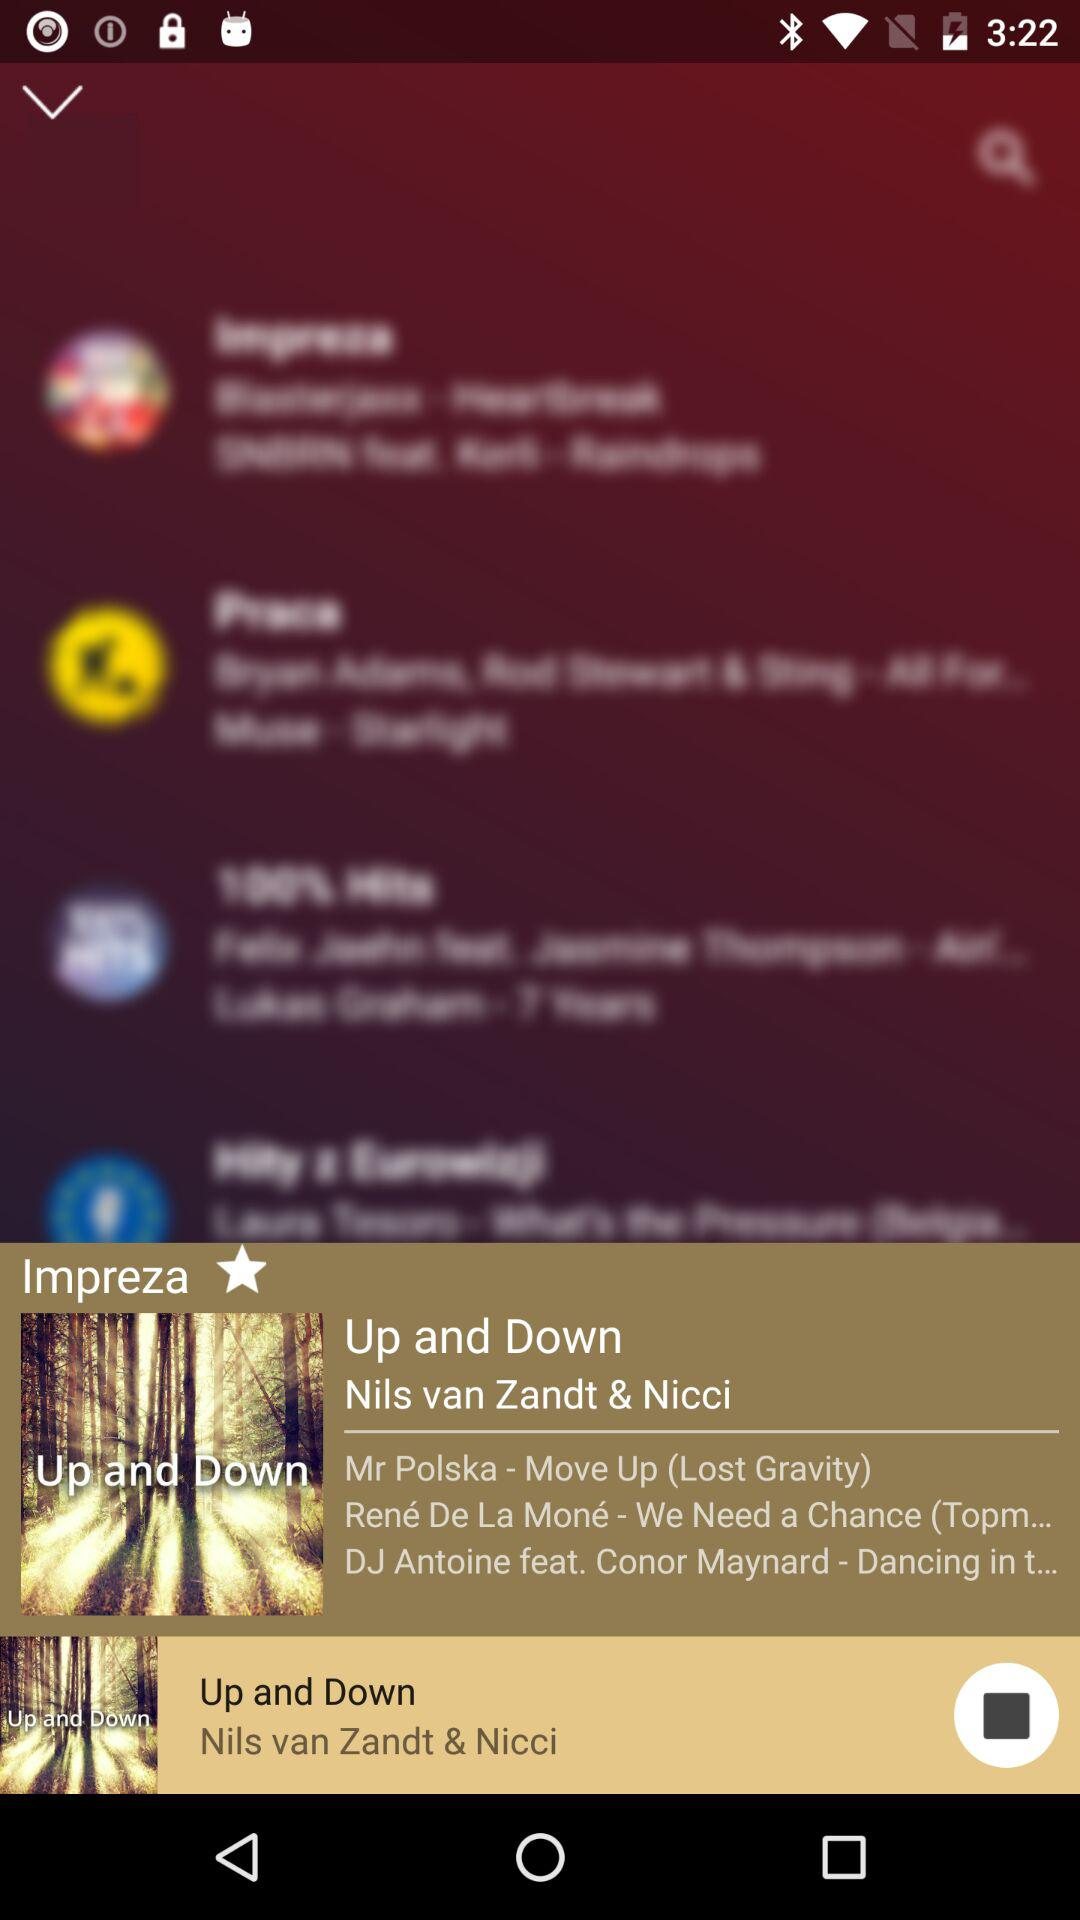Who's the artist of the song "Up and Down"? The artists of the song are "Nils van Zandt & Nicci". 